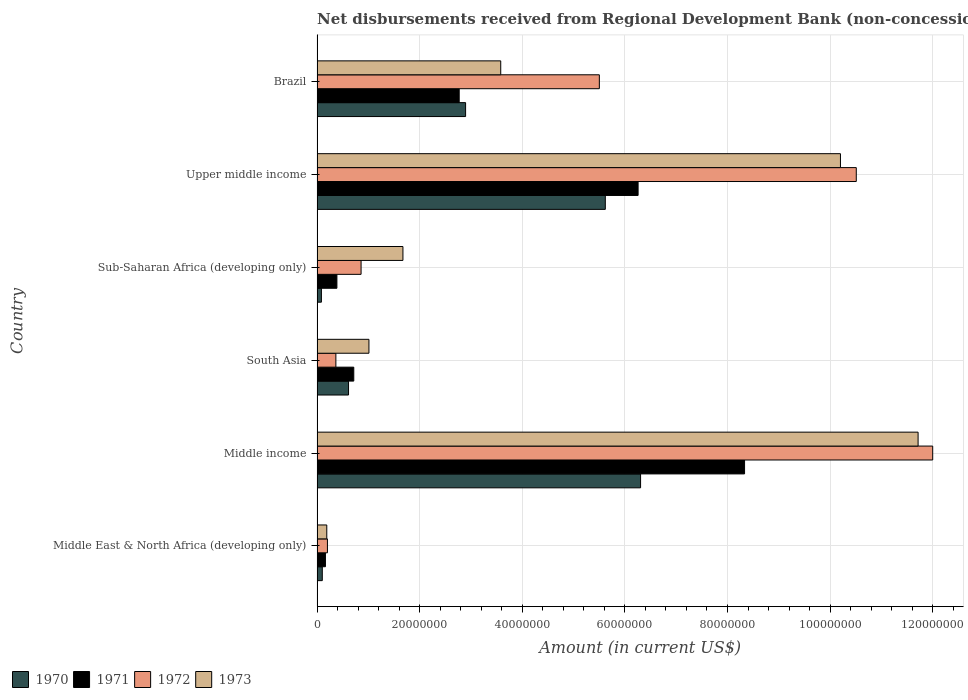How many different coloured bars are there?
Provide a short and direct response. 4. How many bars are there on the 2nd tick from the bottom?
Make the answer very short. 4. What is the label of the 2nd group of bars from the top?
Keep it short and to the point. Upper middle income. What is the amount of disbursements received from Regional Development Bank in 1970 in Sub-Saharan Africa (developing only)?
Provide a short and direct response. 8.50e+05. Across all countries, what is the maximum amount of disbursements received from Regional Development Bank in 1970?
Provide a short and direct response. 6.31e+07. Across all countries, what is the minimum amount of disbursements received from Regional Development Bank in 1972?
Offer a terse response. 2.02e+06. In which country was the amount of disbursements received from Regional Development Bank in 1973 minimum?
Make the answer very short. Middle East & North Africa (developing only). What is the total amount of disbursements received from Regional Development Bank in 1973 in the graph?
Your answer should be very brief. 2.84e+08. What is the difference between the amount of disbursements received from Regional Development Bank in 1970 in Middle income and that in South Asia?
Your answer should be compact. 5.69e+07. What is the difference between the amount of disbursements received from Regional Development Bank in 1970 in Sub-Saharan Africa (developing only) and the amount of disbursements received from Regional Development Bank in 1973 in Middle income?
Your answer should be very brief. -1.16e+08. What is the average amount of disbursements received from Regional Development Bank in 1971 per country?
Offer a very short reply. 3.10e+07. What is the difference between the amount of disbursements received from Regional Development Bank in 1973 and amount of disbursements received from Regional Development Bank in 1971 in South Asia?
Provide a short and direct response. 2.95e+06. What is the ratio of the amount of disbursements received from Regional Development Bank in 1971 in Middle East & North Africa (developing only) to that in Upper middle income?
Your response must be concise. 0.03. Is the amount of disbursements received from Regional Development Bank in 1970 in Middle income less than that in South Asia?
Give a very brief answer. No. What is the difference between the highest and the second highest amount of disbursements received from Regional Development Bank in 1971?
Your answer should be compact. 2.08e+07. What is the difference between the highest and the lowest amount of disbursements received from Regional Development Bank in 1971?
Provide a succinct answer. 8.17e+07. In how many countries, is the amount of disbursements received from Regional Development Bank in 1972 greater than the average amount of disbursements received from Regional Development Bank in 1972 taken over all countries?
Ensure brevity in your answer.  3. Is it the case that in every country, the sum of the amount of disbursements received from Regional Development Bank in 1972 and amount of disbursements received from Regional Development Bank in 1970 is greater than the sum of amount of disbursements received from Regional Development Bank in 1971 and amount of disbursements received from Regional Development Bank in 1973?
Your answer should be compact. No. What does the 4th bar from the bottom in Sub-Saharan Africa (developing only) represents?
Keep it short and to the point. 1973. Is it the case that in every country, the sum of the amount of disbursements received from Regional Development Bank in 1973 and amount of disbursements received from Regional Development Bank in 1971 is greater than the amount of disbursements received from Regional Development Bank in 1970?
Your answer should be compact. Yes. How many bars are there?
Provide a short and direct response. 24. Are the values on the major ticks of X-axis written in scientific E-notation?
Your answer should be very brief. No. How many legend labels are there?
Offer a very short reply. 4. What is the title of the graph?
Provide a short and direct response. Net disbursements received from Regional Development Bank (non-concessional). What is the label or title of the Y-axis?
Provide a short and direct response. Country. What is the Amount (in current US$) in 1970 in Middle East & North Africa (developing only)?
Ensure brevity in your answer.  1.02e+06. What is the Amount (in current US$) in 1971 in Middle East & North Africa (developing only)?
Keep it short and to the point. 1.64e+06. What is the Amount (in current US$) in 1972 in Middle East & North Africa (developing only)?
Offer a very short reply. 2.02e+06. What is the Amount (in current US$) of 1973 in Middle East & North Africa (developing only)?
Your response must be concise. 1.90e+06. What is the Amount (in current US$) in 1970 in Middle income?
Give a very brief answer. 6.31e+07. What is the Amount (in current US$) in 1971 in Middle income?
Your answer should be very brief. 8.33e+07. What is the Amount (in current US$) of 1972 in Middle income?
Provide a succinct answer. 1.20e+08. What is the Amount (in current US$) of 1973 in Middle income?
Make the answer very short. 1.17e+08. What is the Amount (in current US$) of 1970 in South Asia?
Make the answer very short. 6.13e+06. What is the Amount (in current US$) in 1971 in South Asia?
Your response must be concise. 7.16e+06. What is the Amount (in current US$) of 1972 in South Asia?
Your response must be concise. 3.67e+06. What is the Amount (in current US$) in 1973 in South Asia?
Offer a very short reply. 1.01e+07. What is the Amount (in current US$) in 1970 in Sub-Saharan Africa (developing only)?
Offer a very short reply. 8.50e+05. What is the Amount (in current US$) of 1971 in Sub-Saharan Africa (developing only)?
Ensure brevity in your answer.  3.87e+06. What is the Amount (in current US$) of 1972 in Sub-Saharan Africa (developing only)?
Offer a terse response. 8.58e+06. What is the Amount (in current US$) of 1973 in Sub-Saharan Africa (developing only)?
Provide a succinct answer. 1.67e+07. What is the Amount (in current US$) of 1970 in Upper middle income?
Ensure brevity in your answer.  5.62e+07. What is the Amount (in current US$) in 1971 in Upper middle income?
Offer a terse response. 6.26e+07. What is the Amount (in current US$) of 1972 in Upper middle income?
Provide a short and direct response. 1.05e+08. What is the Amount (in current US$) of 1973 in Upper middle income?
Make the answer very short. 1.02e+08. What is the Amount (in current US$) in 1970 in Brazil?
Give a very brief answer. 2.90e+07. What is the Amount (in current US$) in 1971 in Brazil?
Provide a succinct answer. 2.77e+07. What is the Amount (in current US$) in 1972 in Brazil?
Offer a terse response. 5.50e+07. What is the Amount (in current US$) of 1973 in Brazil?
Ensure brevity in your answer.  3.58e+07. Across all countries, what is the maximum Amount (in current US$) of 1970?
Ensure brevity in your answer.  6.31e+07. Across all countries, what is the maximum Amount (in current US$) of 1971?
Ensure brevity in your answer.  8.33e+07. Across all countries, what is the maximum Amount (in current US$) of 1972?
Give a very brief answer. 1.20e+08. Across all countries, what is the maximum Amount (in current US$) of 1973?
Your answer should be very brief. 1.17e+08. Across all countries, what is the minimum Amount (in current US$) of 1970?
Keep it short and to the point. 8.50e+05. Across all countries, what is the minimum Amount (in current US$) of 1971?
Offer a very short reply. 1.64e+06. Across all countries, what is the minimum Amount (in current US$) of 1972?
Your answer should be very brief. 2.02e+06. Across all countries, what is the minimum Amount (in current US$) in 1973?
Your response must be concise. 1.90e+06. What is the total Amount (in current US$) of 1970 in the graph?
Ensure brevity in your answer.  1.56e+08. What is the total Amount (in current US$) of 1971 in the graph?
Your answer should be compact. 1.86e+08. What is the total Amount (in current US$) of 1972 in the graph?
Give a very brief answer. 2.94e+08. What is the total Amount (in current US$) of 1973 in the graph?
Your answer should be compact. 2.84e+08. What is the difference between the Amount (in current US$) of 1970 in Middle East & North Africa (developing only) and that in Middle income?
Your response must be concise. -6.20e+07. What is the difference between the Amount (in current US$) in 1971 in Middle East & North Africa (developing only) and that in Middle income?
Keep it short and to the point. -8.17e+07. What is the difference between the Amount (in current US$) in 1972 in Middle East & North Africa (developing only) and that in Middle income?
Ensure brevity in your answer.  -1.18e+08. What is the difference between the Amount (in current US$) of 1973 in Middle East & North Africa (developing only) and that in Middle income?
Provide a succinct answer. -1.15e+08. What is the difference between the Amount (in current US$) in 1970 in Middle East & North Africa (developing only) and that in South Asia?
Offer a terse response. -5.11e+06. What is the difference between the Amount (in current US$) in 1971 in Middle East & North Africa (developing only) and that in South Asia?
Give a very brief answer. -5.52e+06. What is the difference between the Amount (in current US$) of 1972 in Middle East & North Africa (developing only) and that in South Asia?
Make the answer very short. -1.64e+06. What is the difference between the Amount (in current US$) in 1973 in Middle East & North Africa (developing only) and that in South Asia?
Offer a terse response. -8.22e+06. What is the difference between the Amount (in current US$) of 1970 in Middle East & North Africa (developing only) and that in Sub-Saharan Africa (developing only)?
Your answer should be very brief. 1.71e+05. What is the difference between the Amount (in current US$) of 1971 in Middle East & North Africa (developing only) and that in Sub-Saharan Africa (developing only)?
Offer a terse response. -2.23e+06. What is the difference between the Amount (in current US$) in 1972 in Middle East & North Africa (developing only) and that in Sub-Saharan Africa (developing only)?
Your answer should be very brief. -6.56e+06. What is the difference between the Amount (in current US$) in 1973 in Middle East & North Africa (developing only) and that in Sub-Saharan Africa (developing only)?
Give a very brief answer. -1.48e+07. What is the difference between the Amount (in current US$) in 1970 in Middle East & North Africa (developing only) and that in Upper middle income?
Provide a short and direct response. -5.52e+07. What is the difference between the Amount (in current US$) in 1971 in Middle East & North Africa (developing only) and that in Upper middle income?
Ensure brevity in your answer.  -6.09e+07. What is the difference between the Amount (in current US$) of 1972 in Middle East & North Africa (developing only) and that in Upper middle income?
Your response must be concise. -1.03e+08. What is the difference between the Amount (in current US$) in 1973 in Middle East & North Africa (developing only) and that in Upper middle income?
Offer a terse response. -1.00e+08. What is the difference between the Amount (in current US$) of 1970 in Middle East & North Africa (developing only) and that in Brazil?
Keep it short and to the point. -2.79e+07. What is the difference between the Amount (in current US$) of 1971 in Middle East & North Africa (developing only) and that in Brazil?
Offer a terse response. -2.61e+07. What is the difference between the Amount (in current US$) of 1972 in Middle East & North Africa (developing only) and that in Brazil?
Provide a succinct answer. -5.30e+07. What is the difference between the Amount (in current US$) in 1973 in Middle East & North Africa (developing only) and that in Brazil?
Keep it short and to the point. -3.39e+07. What is the difference between the Amount (in current US$) of 1970 in Middle income and that in South Asia?
Provide a succinct answer. 5.69e+07. What is the difference between the Amount (in current US$) of 1971 in Middle income and that in South Asia?
Your answer should be compact. 7.62e+07. What is the difference between the Amount (in current US$) in 1972 in Middle income and that in South Asia?
Offer a terse response. 1.16e+08. What is the difference between the Amount (in current US$) in 1973 in Middle income and that in South Asia?
Ensure brevity in your answer.  1.07e+08. What is the difference between the Amount (in current US$) in 1970 in Middle income and that in Sub-Saharan Africa (developing only)?
Offer a terse response. 6.22e+07. What is the difference between the Amount (in current US$) in 1971 in Middle income and that in Sub-Saharan Africa (developing only)?
Provide a succinct answer. 7.95e+07. What is the difference between the Amount (in current US$) in 1972 in Middle income and that in Sub-Saharan Africa (developing only)?
Offer a very short reply. 1.11e+08. What is the difference between the Amount (in current US$) of 1973 in Middle income and that in Sub-Saharan Africa (developing only)?
Ensure brevity in your answer.  1.00e+08. What is the difference between the Amount (in current US$) of 1970 in Middle income and that in Upper middle income?
Your answer should be compact. 6.87e+06. What is the difference between the Amount (in current US$) in 1971 in Middle income and that in Upper middle income?
Provide a short and direct response. 2.08e+07. What is the difference between the Amount (in current US$) of 1972 in Middle income and that in Upper middle income?
Provide a short and direct response. 1.49e+07. What is the difference between the Amount (in current US$) of 1973 in Middle income and that in Upper middle income?
Keep it short and to the point. 1.51e+07. What is the difference between the Amount (in current US$) in 1970 in Middle income and that in Brazil?
Your response must be concise. 3.41e+07. What is the difference between the Amount (in current US$) in 1971 in Middle income and that in Brazil?
Offer a very short reply. 5.56e+07. What is the difference between the Amount (in current US$) in 1972 in Middle income and that in Brazil?
Give a very brief answer. 6.50e+07. What is the difference between the Amount (in current US$) of 1973 in Middle income and that in Brazil?
Offer a very short reply. 8.13e+07. What is the difference between the Amount (in current US$) in 1970 in South Asia and that in Sub-Saharan Africa (developing only)?
Give a very brief answer. 5.28e+06. What is the difference between the Amount (in current US$) of 1971 in South Asia and that in Sub-Saharan Africa (developing only)?
Make the answer very short. 3.29e+06. What is the difference between the Amount (in current US$) of 1972 in South Asia and that in Sub-Saharan Africa (developing only)?
Your response must be concise. -4.91e+06. What is the difference between the Amount (in current US$) in 1973 in South Asia and that in Sub-Saharan Africa (developing only)?
Offer a terse response. -6.63e+06. What is the difference between the Amount (in current US$) of 1970 in South Asia and that in Upper middle income?
Your answer should be compact. -5.01e+07. What is the difference between the Amount (in current US$) in 1971 in South Asia and that in Upper middle income?
Your answer should be very brief. -5.54e+07. What is the difference between the Amount (in current US$) in 1972 in South Asia and that in Upper middle income?
Offer a terse response. -1.01e+08. What is the difference between the Amount (in current US$) of 1973 in South Asia and that in Upper middle income?
Give a very brief answer. -9.19e+07. What is the difference between the Amount (in current US$) of 1970 in South Asia and that in Brazil?
Ensure brevity in your answer.  -2.28e+07. What is the difference between the Amount (in current US$) of 1971 in South Asia and that in Brazil?
Provide a short and direct response. -2.05e+07. What is the difference between the Amount (in current US$) in 1972 in South Asia and that in Brazil?
Give a very brief answer. -5.14e+07. What is the difference between the Amount (in current US$) in 1973 in South Asia and that in Brazil?
Your answer should be compact. -2.57e+07. What is the difference between the Amount (in current US$) of 1970 in Sub-Saharan Africa (developing only) and that in Upper middle income?
Your answer should be compact. -5.53e+07. What is the difference between the Amount (in current US$) in 1971 in Sub-Saharan Africa (developing only) and that in Upper middle income?
Your answer should be very brief. -5.87e+07. What is the difference between the Amount (in current US$) in 1972 in Sub-Saharan Africa (developing only) and that in Upper middle income?
Offer a terse response. -9.65e+07. What is the difference between the Amount (in current US$) in 1973 in Sub-Saharan Africa (developing only) and that in Upper middle income?
Make the answer very short. -8.53e+07. What is the difference between the Amount (in current US$) of 1970 in Sub-Saharan Africa (developing only) and that in Brazil?
Provide a succinct answer. -2.81e+07. What is the difference between the Amount (in current US$) of 1971 in Sub-Saharan Africa (developing only) and that in Brazil?
Make the answer very short. -2.38e+07. What is the difference between the Amount (in current US$) of 1972 in Sub-Saharan Africa (developing only) and that in Brazil?
Offer a very short reply. -4.64e+07. What is the difference between the Amount (in current US$) of 1973 in Sub-Saharan Africa (developing only) and that in Brazil?
Your answer should be very brief. -1.91e+07. What is the difference between the Amount (in current US$) of 1970 in Upper middle income and that in Brazil?
Keep it short and to the point. 2.72e+07. What is the difference between the Amount (in current US$) of 1971 in Upper middle income and that in Brazil?
Offer a very short reply. 3.49e+07. What is the difference between the Amount (in current US$) of 1972 in Upper middle income and that in Brazil?
Ensure brevity in your answer.  5.01e+07. What is the difference between the Amount (in current US$) in 1973 in Upper middle income and that in Brazil?
Make the answer very short. 6.62e+07. What is the difference between the Amount (in current US$) of 1970 in Middle East & North Africa (developing only) and the Amount (in current US$) of 1971 in Middle income?
Offer a terse response. -8.23e+07. What is the difference between the Amount (in current US$) in 1970 in Middle East & North Africa (developing only) and the Amount (in current US$) in 1972 in Middle income?
Make the answer very short. -1.19e+08. What is the difference between the Amount (in current US$) of 1970 in Middle East & North Africa (developing only) and the Amount (in current US$) of 1973 in Middle income?
Give a very brief answer. -1.16e+08. What is the difference between the Amount (in current US$) of 1971 in Middle East & North Africa (developing only) and the Amount (in current US$) of 1972 in Middle income?
Offer a terse response. -1.18e+08. What is the difference between the Amount (in current US$) in 1971 in Middle East & North Africa (developing only) and the Amount (in current US$) in 1973 in Middle income?
Provide a short and direct response. -1.16e+08. What is the difference between the Amount (in current US$) of 1972 in Middle East & North Africa (developing only) and the Amount (in current US$) of 1973 in Middle income?
Keep it short and to the point. -1.15e+08. What is the difference between the Amount (in current US$) in 1970 in Middle East & North Africa (developing only) and the Amount (in current US$) in 1971 in South Asia?
Keep it short and to the point. -6.14e+06. What is the difference between the Amount (in current US$) in 1970 in Middle East & North Africa (developing only) and the Amount (in current US$) in 1972 in South Asia?
Keep it short and to the point. -2.65e+06. What is the difference between the Amount (in current US$) in 1970 in Middle East & North Africa (developing only) and the Amount (in current US$) in 1973 in South Asia?
Your answer should be compact. -9.09e+06. What is the difference between the Amount (in current US$) in 1971 in Middle East & North Africa (developing only) and the Amount (in current US$) in 1972 in South Asia?
Offer a very short reply. -2.03e+06. What is the difference between the Amount (in current US$) in 1971 in Middle East & North Africa (developing only) and the Amount (in current US$) in 1973 in South Asia?
Your answer should be very brief. -8.48e+06. What is the difference between the Amount (in current US$) in 1972 in Middle East & North Africa (developing only) and the Amount (in current US$) in 1973 in South Asia?
Offer a very short reply. -8.09e+06. What is the difference between the Amount (in current US$) of 1970 in Middle East & North Africa (developing only) and the Amount (in current US$) of 1971 in Sub-Saharan Africa (developing only)?
Ensure brevity in your answer.  -2.85e+06. What is the difference between the Amount (in current US$) in 1970 in Middle East & North Africa (developing only) and the Amount (in current US$) in 1972 in Sub-Saharan Africa (developing only)?
Provide a short and direct response. -7.56e+06. What is the difference between the Amount (in current US$) in 1970 in Middle East & North Africa (developing only) and the Amount (in current US$) in 1973 in Sub-Saharan Africa (developing only)?
Give a very brief answer. -1.57e+07. What is the difference between the Amount (in current US$) of 1971 in Middle East & North Africa (developing only) and the Amount (in current US$) of 1972 in Sub-Saharan Africa (developing only)?
Offer a terse response. -6.95e+06. What is the difference between the Amount (in current US$) of 1971 in Middle East & North Africa (developing only) and the Amount (in current US$) of 1973 in Sub-Saharan Africa (developing only)?
Keep it short and to the point. -1.51e+07. What is the difference between the Amount (in current US$) of 1972 in Middle East & North Africa (developing only) and the Amount (in current US$) of 1973 in Sub-Saharan Africa (developing only)?
Provide a short and direct response. -1.47e+07. What is the difference between the Amount (in current US$) of 1970 in Middle East & North Africa (developing only) and the Amount (in current US$) of 1971 in Upper middle income?
Make the answer very short. -6.16e+07. What is the difference between the Amount (in current US$) of 1970 in Middle East & North Africa (developing only) and the Amount (in current US$) of 1972 in Upper middle income?
Offer a very short reply. -1.04e+08. What is the difference between the Amount (in current US$) of 1970 in Middle East & North Africa (developing only) and the Amount (in current US$) of 1973 in Upper middle income?
Your answer should be compact. -1.01e+08. What is the difference between the Amount (in current US$) of 1971 in Middle East & North Africa (developing only) and the Amount (in current US$) of 1972 in Upper middle income?
Ensure brevity in your answer.  -1.03e+08. What is the difference between the Amount (in current US$) of 1971 in Middle East & North Africa (developing only) and the Amount (in current US$) of 1973 in Upper middle income?
Provide a succinct answer. -1.00e+08. What is the difference between the Amount (in current US$) in 1972 in Middle East & North Africa (developing only) and the Amount (in current US$) in 1973 in Upper middle income?
Your answer should be very brief. -1.00e+08. What is the difference between the Amount (in current US$) of 1970 in Middle East & North Africa (developing only) and the Amount (in current US$) of 1971 in Brazil?
Give a very brief answer. -2.67e+07. What is the difference between the Amount (in current US$) in 1970 in Middle East & North Africa (developing only) and the Amount (in current US$) in 1972 in Brazil?
Your answer should be very brief. -5.40e+07. What is the difference between the Amount (in current US$) in 1970 in Middle East & North Africa (developing only) and the Amount (in current US$) in 1973 in Brazil?
Provide a succinct answer. -3.48e+07. What is the difference between the Amount (in current US$) in 1971 in Middle East & North Africa (developing only) and the Amount (in current US$) in 1972 in Brazil?
Give a very brief answer. -5.34e+07. What is the difference between the Amount (in current US$) in 1971 in Middle East & North Africa (developing only) and the Amount (in current US$) in 1973 in Brazil?
Provide a short and direct response. -3.42e+07. What is the difference between the Amount (in current US$) in 1972 in Middle East & North Africa (developing only) and the Amount (in current US$) in 1973 in Brazil?
Offer a very short reply. -3.38e+07. What is the difference between the Amount (in current US$) of 1970 in Middle income and the Amount (in current US$) of 1971 in South Asia?
Ensure brevity in your answer.  5.59e+07. What is the difference between the Amount (in current US$) of 1970 in Middle income and the Amount (in current US$) of 1972 in South Asia?
Offer a very short reply. 5.94e+07. What is the difference between the Amount (in current US$) in 1970 in Middle income and the Amount (in current US$) in 1973 in South Asia?
Keep it short and to the point. 5.29e+07. What is the difference between the Amount (in current US$) of 1971 in Middle income and the Amount (in current US$) of 1972 in South Asia?
Your answer should be compact. 7.97e+07. What is the difference between the Amount (in current US$) in 1971 in Middle income and the Amount (in current US$) in 1973 in South Asia?
Your answer should be compact. 7.32e+07. What is the difference between the Amount (in current US$) in 1972 in Middle income and the Amount (in current US$) in 1973 in South Asia?
Offer a terse response. 1.10e+08. What is the difference between the Amount (in current US$) in 1970 in Middle income and the Amount (in current US$) in 1971 in Sub-Saharan Africa (developing only)?
Offer a terse response. 5.92e+07. What is the difference between the Amount (in current US$) of 1970 in Middle income and the Amount (in current US$) of 1972 in Sub-Saharan Africa (developing only)?
Make the answer very short. 5.45e+07. What is the difference between the Amount (in current US$) in 1970 in Middle income and the Amount (in current US$) in 1973 in Sub-Saharan Africa (developing only)?
Give a very brief answer. 4.63e+07. What is the difference between the Amount (in current US$) of 1971 in Middle income and the Amount (in current US$) of 1972 in Sub-Saharan Africa (developing only)?
Keep it short and to the point. 7.47e+07. What is the difference between the Amount (in current US$) of 1971 in Middle income and the Amount (in current US$) of 1973 in Sub-Saharan Africa (developing only)?
Your answer should be very brief. 6.66e+07. What is the difference between the Amount (in current US$) in 1972 in Middle income and the Amount (in current US$) in 1973 in Sub-Saharan Africa (developing only)?
Your response must be concise. 1.03e+08. What is the difference between the Amount (in current US$) of 1970 in Middle income and the Amount (in current US$) of 1971 in Upper middle income?
Provide a short and direct response. 4.82e+05. What is the difference between the Amount (in current US$) of 1970 in Middle income and the Amount (in current US$) of 1972 in Upper middle income?
Your response must be concise. -4.20e+07. What is the difference between the Amount (in current US$) of 1970 in Middle income and the Amount (in current US$) of 1973 in Upper middle income?
Make the answer very short. -3.90e+07. What is the difference between the Amount (in current US$) of 1971 in Middle income and the Amount (in current US$) of 1972 in Upper middle income?
Your response must be concise. -2.18e+07. What is the difference between the Amount (in current US$) of 1971 in Middle income and the Amount (in current US$) of 1973 in Upper middle income?
Give a very brief answer. -1.87e+07. What is the difference between the Amount (in current US$) of 1972 in Middle income and the Amount (in current US$) of 1973 in Upper middle income?
Your answer should be very brief. 1.80e+07. What is the difference between the Amount (in current US$) of 1970 in Middle income and the Amount (in current US$) of 1971 in Brazil?
Your answer should be very brief. 3.54e+07. What is the difference between the Amount (in current US$) in 1970 in Middle income and the Amount (in current US$) in 1972 in Brazil?
Your response must be concise. 8.04e+06. What is the difference between the Amount (in current US$) of 1970 in Middle income and the Amount (in current US$) of 1973 in Brazil?
Your answer should be very brief. 2.73e+07. What is the difference between the Amount (in current US$) in 1971 in Middle income and the Amount (in current US$) in 1972 in Brazil?
Offer a very short reply. 2.83e+07. What is the difference between the Amount (in current US$) in 1971 in Middle income and the Amount (in current US$) in 1973 in Brazil?
Ensure brevity in your answer.  4.75e+07. What is the difference between the Amount (in current US$) of 1972 in Middle income and the Amount (in current US$) of 1973 in Brazil?
Your answer should be very brief. 8.42e+07. What is the difference between the Amount (in current US$) of 1970 in South Asia and the Amount (in current US$) of 1971 in Sub-Saharan Africa (developing only)?
Your answer should be compact. 2.26e+06. What is the difference between the Amount (in current US$) of 1970 in South Asia and the Amount (in current US$) of 1972 in Sub-Saharan Africa (developing only)?
Your response must be concise. -2.45e+06. What is the difference between the Amount (in current US$) of 1970 in South Asia and the Amount (in current US$) of 1973 in Sub-Saharan Africa (developing only)?
Offer a very short reply. -1.06e+07. What is the difference between the Amount (in current US$) of 1971 in South Asia and the Amount (in current US$) of 1972 in Sub-Saharan Africa (developing only)?
Your answer should be very brief. -1.42e+06. What is the difference between the Amount (in current US$) of 1971 in South Asia and the Amount (in current US$) of 1973 in Sub-Saharan Africa (developing only)?
Offer a very short reply. -9.58e+06. What is the difference between the Amount (in current US$) in 1972 in South Asia and the Amount (in current US$) in 1973 in Sub-Saharan Africa (developing only)?
Offer a terse response. -1.31e+07. What is the difference between the Amount (in current US$) in 1970 in South Asia and the Amount (in current US$) in 1971 in Upper middle income?
Your response must be concise. -5.64e+07. What is the difference between the Amount (in current US$) in 1970 in South Asia and the Amount (in current US$) in 1972 in Upper middle income?
Give a very brief answer. -9.90e+07. What is the difference between the Amount (in current US$) of 1970 in South Asia and the Amount (in current US$) of 1973 in Upper middle income?
Provide a short and direct response. -9.59e+07. What is the difference between the Amount (in current US$) in 1971 in South Asia and the Amount (in current US$) in 1972 in Upper middle income?
Provide a short and direct response. -9.79e+07. What is the difference between the Amount (in current US$) in 1971 in South Asia and the Amount (in current US$) in 1973 in Upper middle income?
Your response must be concise. -9.49e+07. What is the difference between the Amount (in current US$) in 1972 in South Asia and the Amount (in current US$) in 1973 in Upper middle income?
Your answer should be very brief. -9.83e+07. What is the difference between the Amount (in current US$) in 1970 in South Asia and the Amount (in current US$) in 1971 in Brazil?
Your response must be concise. -2.16e+07. What is the difference between the Amount (in current US$) of 1970 in South Asia and the Amount (in current US$) of 1972 in Brazil?
Your answer should be compact. -4.89e+07. What is the difference between the Amount (in current US$) in 1970 in South Asia and the Amount (in current US$) in 1973 in Brazil?
Offer a very short reply. -2.97e+07. What is the difference between the Amount (in current US$) in 1971 in South Asia and the Amount (in current US$) in 1972 in Brazil?
Your answer should be compact. -4.79e+07. What is the difference between the Amount (in current US$) of 1971 in South Asia and the Amount (in current US$) of 1973 in Brazil?
Your answer should be compact. -2.86e+07. What is the difference between the Amount (in current US$) in 1972 in South Asia and the Amount (in current US$) in 1973 in Brazil?
Provide a succinct answer. -3.21e+07. What is the difference between the Amount (in current US$) of 1970 in Sub-Saharan Africa (developing only) and the Amount (in current US$) of 1971 in Upper middle income?
Keep it short and to the point. -6.17e+07. What is the difference between the Amount (in current US$) in 1970 in Sub-Saharan Africa (developing only) and the Amount (in current US$) in 1972 in Upper middle income?
Offer a terse response. -1.04e+08. What is the difference between the Amount (in current US$) of 1970 in Sub-Saharan Africa (developing only) and the Amount (in current US$) of 1973 in Upper middle income?
Offer a very short reply. -1.01e+08. What is the difference between the Amount (in current US$) in 1971 in Sub-Saharan Africa (developing only) and the Amount (in current US$) in 1972 in Upper middle income?
Offer a terse response. -1.01e+08. What is the difference between the Amount (in current US$) of 1971 in Sub-Saharan Africa (developing only) and the Amount (in current US$) of 1973 in Upper middle income?
Your answer should be compact. -9.81e+07. What is the difference between the Amount (in current US$) of 1972 in Sub-Saharan Africa (developing only) and the Amount (in current US$) of 1973 in Upper middle income?
Ensure brevity in your answer.  -9.34e+07. What is the difference between the Amount (in current US$) of 1970 in Sub-Saharan Africa (developing only) and the Amount (in current US$) of 1971 in Brazil?
Keep it short and to the point. -2.69e+07. What is the difference between the Amount (in current US$) in 1970 in Sub-Saharan Africa (developing only) and the Amount (in current US$) in 1972 in Brazil?
Your answer should be very brief. -5.42e+07. What is the difference between the Amount (in current US$) of 1970 in Sub-Saharan Africa (developing only) and the Amount (in current US$) of 1973 in Brazil?
Offer a very short reply. -3.50e+07. What is the difference between the Amount (in current US$) of 1971 in Sub-Saharan Africa (developing only) and the Amount (in current US$) of 1972 in Brazil?
Your response must be concise. -5.12e+07. What is the difference between the Amount (in current US$) of 1971 in Sub-Saharan Africa (developing only) and the Amount (in current US$) of 1973 in Brazil?
Make the answer very short. -3.19e+07. What is the difference between the Amount (in current US$) of 1972 in Sub-Saharan Africa (developing only) and the Amount (in current US$) of 1973 in Brazil?
Provide a short and direct response. -2.72e+07. What is the difference between the Amount (in current US$) of 1970 in Upper middle income and the Amount (in current US$) of 1971 in Brazil?
Your response must be concise. 2.85e+07. What is the difference between the Amount (in current US$) in 1970 in Upper middle income and the Amount (in current US$) in 1972 in Brazil?
Your answer should be very brief. 1.16e+06. What is the difference between the Amount (in current US$) in 1970 in Upper middle income and the Amount (in current US$) in 1973 in Brazil?
Your answer should be compact. 2.04e+07. What is the difference between the Amount (in current US$) of 1971 in Upper middle income and the Amount (in current US$) of 1972 in Brazil?
Ensure brevity in your answer.  7.55e+06. What is the difference between the Amount (in current US$) in 1971 in Upper middle income and the Amount (in current US$) in 1973 in Brazil?
Provide a succinct answer. 2.68e+07. What is the difference between the Amount (in current US$) of 1972 in Upper middle income and the Amount (in current US$) of 1973 in Brazil?
Your answer should be very brief. 6.93e+07. What is the average Amount (in current US$) in 1970 per country?
Keep it short and to the point. 2.60e+07. What is the average Amount (in current US$) in 1971 per country?
Your answer should be compact. 3.10e+07. What is the average Amount (in current US$) of 1972 per country?
Your answer should be compact. 4.91e+07. What is the average Amount (in current US$) of 1973 per country?
Give a very brief answer. 4.73e+07. What is the difference between the Amount (in current US$) of 1970 and Amount (in current US$) of 1971 in Middle East & North Africa (developing only)?
Your answer should be compact. -6.14e+05. What is the difference between the Amount (in current US$) of 1970 and Amount (in current US$) of 1972 in Middle East & North Africa (developing only)?
Ensure brevity in your answer.  -1.00e+06. What is the difference between the Amount (in current US$) of 1970 and Amount (in current US$) of 1973 in Middle East & North Africa (developing only)?
Ensure brevity in your answer.  -8.75e+05. What is the difference between the Amount (in current US$) in 1971 and Amount (in current US$) in 1972 in Middle East & North Africa (developing only)?
Give a very brief answer. -3.89e+05. What is the difference between the Amount (in current US$) in 1971 and Amount (in current US$) in 1973 in Middle East & North Africa (developing only)?
Provide a short and direct response. -2.61e+05. What is the difference between the Amount (in current US$) in 1972 and Amount (in current US$) in 1973 in Middle East & North Africa (developing only)?
Your answer should be very brief. 1.28e+05. What is the difference between the Amount (in current US$) of 1970 and Amount (in current US$) of 1971 in Middle income?
Your answer should be very brief. -2.03e+07. What is the difference between the Amount (in current US$) in 1970 and Amount (in current US$) in 1972 in Middle income?
Offer a terse response. -5.69e+07. What is the difference between the Amount (in current US$) in 1970 and Amount (in current US$) in 1973 in Middle income?
Your answer should be very brief. -5.41e+07. What is the difference between the Amount (in current US$) of 1971 and Amount (in current US$) of 1972 in Middle income?
Your answer should be very brief. -3.67e+07. What is the difference between the Amount (in current US$) of 1971 and Amount (in current US$) of 1973 in Middle income?
Make the answer very short. -3.38e+07. What is the difference between the Amount (in current US$) of 1972 and Amount (in current US$) of 1973 in Middle income?
Give a very brief answer. 2.85e+06. What is the difference between the Amount (in current US$) in 1970 and Amount (in current US$) in 1971 in South Asia?
Ensure brevity in your answer.  -1.02e+06. What is the difference between the Amount (in current US$) in 1970 and Amount (in current US$) in 1972 in South Asia?
Provide a short and direct response. 2.46e+06. What is the difference between the Amount (in current US$) in 1970 and Amount (in current US$) in 1973 in South Asia?
Offer a terse response. -3.98e+06. What is the difference between the Amount (in current US$) of 1971 and Amount (in current US$) of 1972 in South Asia?
Make the answer very short. 3.49e+06. What is the difference between the Amount (in current US$) of 1971 and Amount (in current US$) of 1973 in South Asia?
Offer a terse response. -2.95e+06. What is the difference between the Amount (in current US$) of 1972 and Amount (in current US$) of 1973 in South Asia?
Your answer should be very brief. -6.44e+06. What is the difference between the Amount (in current US$) in 1970 and Amount (in current US$) in 1971 in Sub-Saharan Africa (developing only)?
Offer a very short reply. -3.02e+06. What is the difference between the Amount (in current US$) in 1970 and Amount (in current US$) in 1972 in Sub-Saharan Africa (developing only)?
Offer a very short reply. -7.73e+06. What is the difference between the Amount (in current US$) of 1970 and Amount (in current US$) of 1973 in Sub-Saharan Africa (developing only)?
Give a very brief answer. -1.59e+07. What is the difference between the Amount (in current US$) in 1971 and Amount (in current US$) in 1972 in Sub-Saharan Africa (developing only)?
Your answer should be very brief. -4.71e+06. What is the difference between the Amount (in current US$) of 1971 and Amount (in current US$) of 1973 in Sub-Saharan Africa (developing only)?
Ensure brevity in your answer.  -1.29e+07. What is the difference between the Amount (in current US$) of 1972 and Amount (in current US$) of 1973 in Sub-Saharan Africa (developing only)?
Provide a short and direct response. -8.16e+06. What is the difference between the Amount (in current US$) of 1970 and Amount (in current US$) of 1971 in Upper middle income?
Your answer should be very brief. -6.39e+06. What is the difference between the Amount (in current US$) in 1970 and Amount (in current US$) in 1972 in Upper middle income?
Provide a succinct answer. -4.89e+07. What is the difference between the Amount (in current US$) in 1970 and Amount (in current US$) in 1973 in Upper middle income?
Offer a very short reply. -4.58e+07. What is the difference between the Amount (in current US$) in 1971 and Amount (in current US$) in 1972 in Upper middle income?
Ensure brevity in your answer.  -4.25e+07. What is the difference between the Amount (in current US$) in 1971 and Amount (in current US$) in 1973 in Upper middle income?
Keep it short and to the point. -3.94e+07. What is the difference between the Amount (in current US$) in 1972 and Amount (in current US$) in 1973 in Upper middle income?
Offer a terse response. 3.08e+06. What is the difference between the Amount (in current US$) in 1970 and Amount (in current US$) in 1971 in Brazil?
Give a very brief answer. 1.25e+06. What is the difference between the Amount (in current US$) of 1970 and Amount (in current US$) of 1972 in Brazil?
Make the answer very short. -2.61e+07. What is the difference between the Amount (in current US$) in 1970 and Amount (in current US$) in 1973 in Brazil?
Your answer should be very brief. -6.85e+06. What is the difference between the Amount (in current US$) of 1971 and Amount (in current US$) of 1972 in Brazil?
Ensure brevity in your answer.  -2.73e+07. What is the difference between the Amount (in current US$) of 1971 and Amount (in current US$) of 1973 in Brazil?
Give a very brief answer. -8.10e+06. What is the difference between the Amount (in current US$) of 1972 and Amount (in current US$) of 1973 in Brazil?
Your answer should be compact. 1.92e+07. What is the ratio of the Amount (in current US$) of 1970 in Middle East & North Africa (developing only) to that in Middle income?
Your answer should be compact. 0.02. What is the ratio of the Amount (in current US$) in 1971 in Middle East & North Africa (developing only) to that in Middle income?
Offer a very short reply. 0.02. What is the ratio of the Amount (in current US$) in 1972 in Middle East & North Africa (developing only) to that in Middle income?
Your response must be concise. 0.02. What is the ratio of the Amount (in current US$) in 1973 in Middle East & North Africa (developing only) to that in Middle income?
Your response must be concise. 0.02. What is the ratio of the Amount (in current US$) of 1970 in Middle East & North Africa (developing only) to that in South Asia?
Your response must be concise. 0.17. What is the ratio of the Amount (in current US$) in 1971 in Middle East & North Africa (developing only) to that in South Asia?
Make the answer very short. 0.23. What is the ratio of the Amount (in current US$) in 1972 in Middle East & North Africa (developing only) to that in South Asia?
Provide a short and direct response. 0.55. What is the ratio of the Amount (in current US$) in 1973 in Middle East & North Africa (developing only) to that in South Asia?
Give a very brief answer. 0.19. What is the ratio of the Amount (in current US$) in 1970 in Middle East & North Africa (developing only) to that in Sub-Saharan Africa (developing only)?
Provide a succinct answer. 1.2. What is the ratio of the Amount (in current US$) of 1971 in Middle East & North Africa (developing only) to that in Sub-Saharan Africa (developing only)?
Your response must be concise. 0.42. What is the ratio of the Amount (in current US$) in 1972 in Middle East & North Africa (developing only) to that in Sub-Saharan Africa (developing only)?
Offer a very short reply. 0.24. What is the ratio of the Amount (in current US$) of 1973 in Middle East & North Africa (developing only) to that in Sub-Saharan Africa (developing only)?
Provide a short and direct response. 0.11. What is the ratio of the Amount (in current US$) of 1970 in Middle East & North Africa (developing only) to that in Upper middle income?
Your answer should be compact. 0.02. What is the ratio of the Amount (in current US$) of 1971 in Middle East & North Africa (developing only) to that in Upper middle income?
Offer a very short reply. 0.03. What is the ratio of the Amount (in current US$) in 1972 in Middle East & North Africa (developing only) to that in Upper middle income?
Provide a succinct answer. 0.02. What is the ratio of the Amount (in current US$) of 1973 in Middle East & North Africa (developing only) to that in Upper middle income?
Offer a very short reply. 0.02. What is the ratio of the Amount (in current US$) of 1970 in Middle East & North Africa (developing only) to that in Brazil?
Provide a succinct answer. 0.04. What is the ratio of the Amount (in current US$) of 1971 in Middle East & North Africa (developing only) to that in Brazil?
Make the answer very short. 0.06. What is the ratio of the Amount (in current US$) of 1972 in Middle East & North Africa (developing only) to that in Brazil?
Provide a succinct answer. 0.04. What is the ratio of the Amount (in current US$) of 1973 in Middle East & North Africa (developing only) to that in Brazil?
Make the answer very short. 0.05. What is the ratio of the Amount (in current US$) of 1970 in Middle income to that in South Asia?
Your answer should be compact. 10.28. What is the ratio of the Amount (in current US$) of 1971 in Middle income to that in South Asia?
Your answer should be very brief. 11.64. What is the ratio of the Amount (in current US$) of 1972 in Middle income to that in South Asia?
Provide a short and direct response. 32.71. What is the ratio of the Amount (in current US$) in 1973 in Middle income to that in South Asia?
Offer a terse response. 11.58. What is the ratio of the Amount (in current US$) of 1970 in Middle income to that in Sub-Saharan Africa (developing only)?
Keep it short and to the point. 74.18. What is the ratio of the Amount (in current US$) of 1971 in Middle income to that in Sub-Saharan Africa (developing only)?
Provide a short and direct response. 21.54. What is the ratio of the Amount (in current US$) in 1972 in Middle income to that in Sub-Saharan Africa (developing only)?
Offer a very short reply. 13.98. What is the ratio of the Amount (in current US$) of 1973 in Middle income to that in Sub-Saharan Africa (developing only)?
Your answer should be very brief. 7. What is the ratio of the Amount (in current US$) of 1970 in Middle income to that in Upper middle income?
Your response must be concise. 1.12. What is the ratio of the Amount (in current US$) in 1971 in Middle income to that in Upper middle income?
Make the answer very short. 1.33. What is the ratio of the Amount (in current US$) in 1972 in Middle income to that in Upper middle income?
Give a very brief answer. 1.14. What is the ratio of the Amount (in current US$) of 1973 in Middle income to that in Upper middle income?
Offer a very short reply. 1.15. What is the ratio of the Amount (in current US$) in 1970 in Middle income to that in Brazil?
Offer a very short reply. 2.18. What is the ratio of the Amount (in current US$) of 1971 in Middle income to that in Brazil?
Your answer should be very brief. 3.01. What is the ratio of the Amount (in current US$) in 1972 in Middle income to that in Brazil?
Provide a short and direct response. 2.18. What is the ratio of the Amount (in current US$) in 1973 in Middle income to that in Brazil?
Offer a very short reply. 3.27. What is the ratio of the Amount (in current US$) of 1970 in South Asia to that in Sub-Saharan Africa (developing only)?
Provide a short and direct response. 7.22. What is the ratio of the Amount (in current US$) in 1971 in South Asia to that in Sub-Saharan Africa (developing only)?
Your answer should be very brief. 1.85. What is the ratio of the Amount (in current US$) of 1972 in South Asia to that in Sub-Saharan Africa (developing only)?
Your answer should be very brief. 0.43. What is the ratio of the Amount (in current US$) of 1973 in South Asia to that in Sub-Saharan Africa (developing only)?
Your response must be concise. 0.6. What is the ratio of the Amount (in current US$) in 1970 in South Asia to that in Upper middle income?
Your response must be concise. 0.11. What is the ratio of the Amount (in current US$) of 1971 in South Asia to that in Upper middle income?
Your response must be concise. 0.11. What is the ratio of the Amount (in current US$) of 1972 in South Asia to that in Upper middle income?
Keep it short and to the point. 0.03. What is the ratio of the Amount (in current US$) in 1973 in South Asia to that in Upper middle income?
Ensure brevity in your answer.  0.1. What is the ratio of the Amount (in current US$) of 1970 in South Asia to that in Brazil?
Offer a terse response. 0.21. What is the ratio of the Amount (in current US$) of 1971 in South Asia to that in Brazil?
Your response must be concise. 0.26. What is the ratio of the Amount (in current US$) of 1972 in South Asia to that in Brazil?
Give a very brief answer. 0.07. What is the ratio of the Amount (in current US$) in 1973 in South Asia to that in Brazil?
Your answer should be very brief. 0.28. What is the ratio of the Amount (in current US$) of 1970 in Sub-Saharan Africa (developing only) to that in Upper middle income?
Provide a short and direct response. 0.02. What is the ratio of the Amount (in current US$) in 1971 in Sub-Saharan Africa (developing only) to that in Upper middle income?
Keep it short and to the point. 0.06. What is the ratio of the Amount (in current US$) in 1972 in Sub-Saharan Africa (developing only) to that in Upper middle income?
Provide a succinct answer. 0.08. What is the ratio of the Amount (in current US$) of 1973 in Sub-Saharan Africa (developing only) to that in Upper middle income?
Offer a terse response. 0.16. What is the ratio of the Amount (in current US$) of 1970 in Sub-Saharan Africa (developing only) to that in Brazil?
Offer a very short reply. 0.03. What is the ratio of the Amount (in current US$) in 1971 in Sub-Saharan Africa (developing only) to that in Brazil?
Ensure brevity in your answer.  0.14. What is the ratio of the Amount (in current US$) in 1972 in Sub-Saharan Africa (developing only) to that in Brazil?
Your answer should be compact. 0.16. What is the ratio of the Amount (in current US$) of 1973 in Sub-Saharan Africa (developing only) to that in Brazil?
Offer a very short reply. 0.47. What is the ratio of the Amount (in current US$) in 1970 in Upper middle income to that in Brazil?
Your response must be concise. 1.94. What is the ratio of the Amount (in current US$) of 1971 in Upper middle income to that in Brazil?
Your answer should be very brief. 2.26. What is the ratio of the Amount (in current US$) of 1972 in Upper middle income to that in Brazil?
Give a very brief answer. 1.91. What is the ratio of the Amount (in current US$) in 1973 in Upper middle income to that in Brazil?
Your response must be concise. 2.85. What is the difference between the highest and the second highest Amount (in current US$) of 1970?
Keep it short and to the point. 6.87e+06. What is the difference between the highest and the second highest Amount (in current US$) in 1971?
Give a very brief answer. 2.08e+07. What is the difference between the highest and the second highest Amount (in current US$) of 1972?
Ensure brevity in your answer.  1.49e+07. What is the difference between the highest and the second highest Amount (in current US$) in 1973?
Your response must be concise. 1.51e+07. What is the difference between the highest and the lowest Amount (in current US$) of 1970?
Your answer should be compact. 6.22e+07. What is the difference between the highest and the lowest Amount (in current US$) of 1971?
Offer a very short reply. 8.17e+07. What is the difference between the highest and the lowest Amount (in current US$) of 1972?
Your answer should be compact. 1.18e+08. What is the difference between the highest and the lowest Amount (in current US$) of 1973?
Provide a short and direct response. 1.15e+08. 